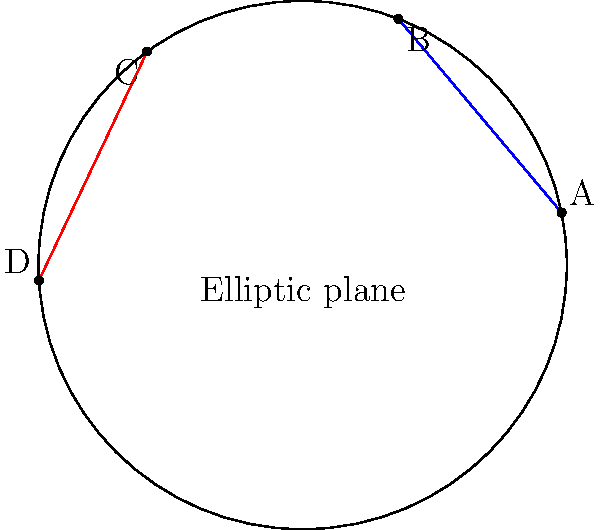In elliptic geometry, as represented on this sphere, how many points of intersection do the blue and red lines have? How does this relate to the concept of parallel lines in elliptic geometry? To understand this concept, let's follow these steps:

1. In elliptic geometry, the surface of a sphere represents the geometric plane.

2. "Straight lines" in elliptic geometry are represented by great circles, which are the largest circles that can be drawn on the surface of a sphere.

3. In the given diagram, the blue and red lines represent portions of great circles on the sphere.

4. Unlike in Euclidean geometry, these "lines" (great circles) always intersect at two points on opposite sides of the sphere.

5. This is true for any two distinct great circles on a sphere.

6. As a result, in elliptic geometry, there are no parallel lines. All lines (great circles) intersect.

7. This fundamentally differs from Euclidean geometry, where parallel lines never intersect.

8. The concept of parallelism, as we understand it in Euclidean geometry, doesn't exist in elliptic geometry.

Therefore, the blue and red lines in the diagram will always intersect at two points, even if these points are not visible in the current view of the sphere.
Answer: Two intersection points; parallel lines do not exist in elliptic geometry. 